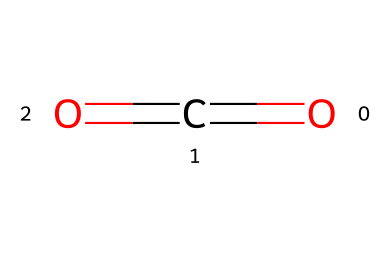what is the name of this chemical? The SMILES representation O=C=O corresponds to carbon dioxide, which is its common name.
Answer: carbon dioxide how many oxygen atoms are present in the molecule? Analyzing the SMILES notation O=C=O, we can see that there are two oxygen atoms bonded to a single carbon atom.
Answer: two what type of chemical bond connects carbon and oxygen in this molecule? In the structure indicated by the SMILES O=C=O, the carbon atom is double-bonded to each of the two oxygen atoms, leading to the conclusion that the bond type is a double bond.
Answer: double bond what is the role of carbon dioxide in eco-friendly cooling systems? Carbon dioxide functions as a natural refrigerant, which means it absorbs heat during the cooling process and helps reduce environmental impact due to its lower global warming potential compared to traditional refrigerants.
Answer: natural refrigerant how does the molecular structure of carbon dioxide affect its refrigerant properties? The linear structure of carbon dioxide (C=O bonds on both sides of carbon) allows it to efficiently absorb and transfer heat, enhancing its refrigerant capacity. This structural configuration contributes to its effectiveness in cooling applications.
Answer: enhances heat transfer why is carbon dioxide considered eco-friendly compared to traditional refrigerants? Carbon dioxide has a significantly lower global warming potential compared to many conventional refrigerants, which often contain harmful hydrocarbons or fluorocarbons that contribute to ozone depletion and climate change.
Answer: lower global warming potential 